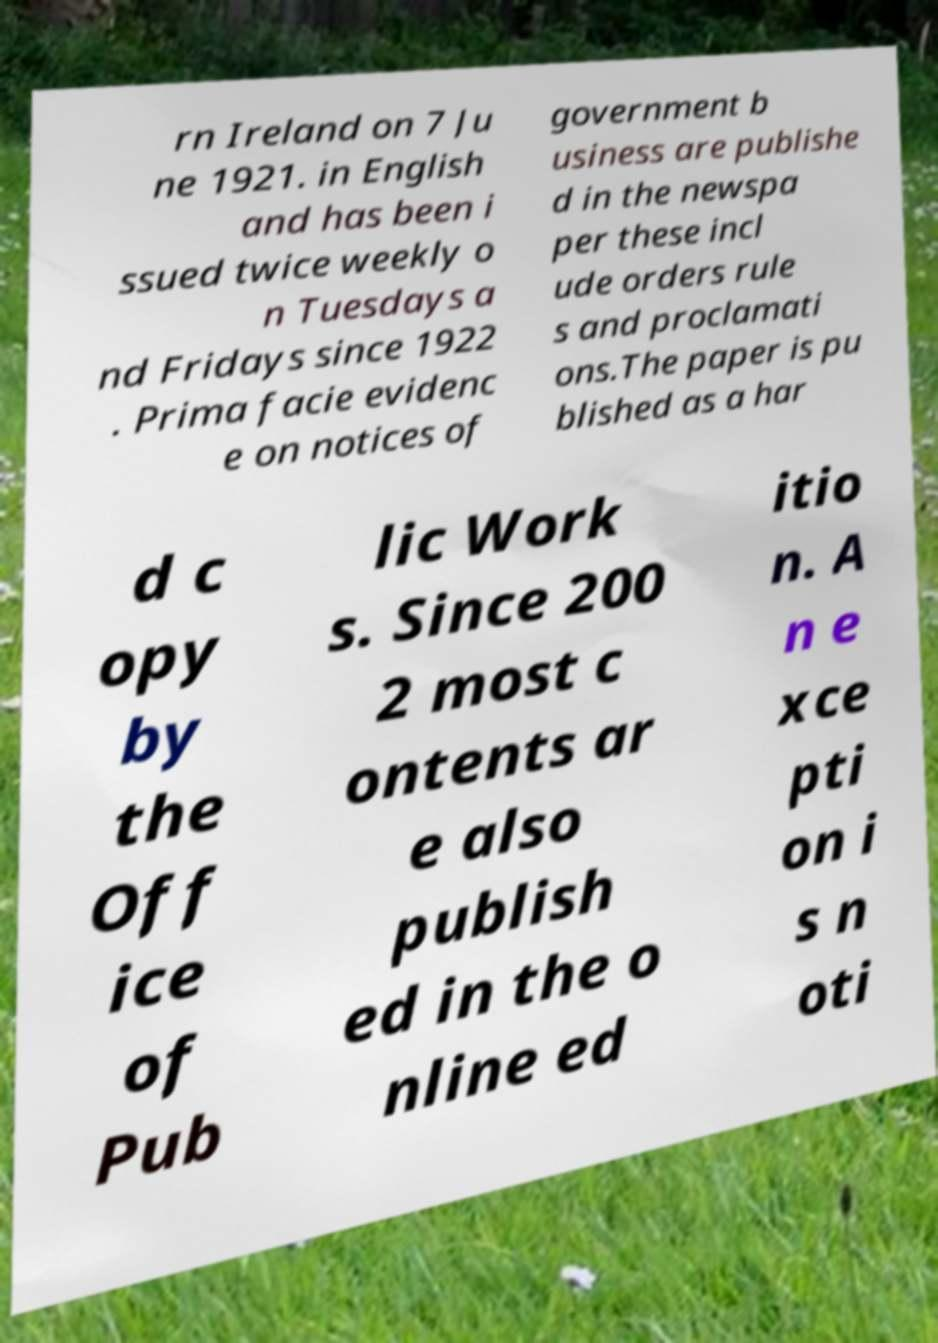Please read and relay the text visible in this image. What does it say? rn Ireland on 7 Ju ne 1921. in English and has been i ssued twice weekly o n Tuesdays a nd Fridays since 1922 . Prima facie evidenc e on notices of government b usiness are publishe d in the newspa per these incl ude orders rule s and proclamati ons.The paper is pu blished as a har d c opy by the Off ice of Pub lic Work s. Since 200 2 most c ontents ar e also publish ed in the o nline ed itio n. A n e xce pti on i s n oti 